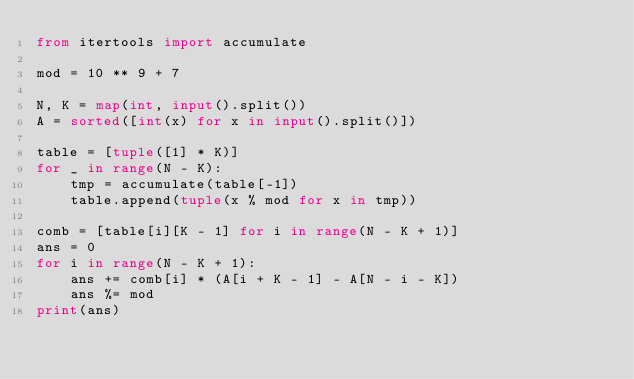Convert code to text. <code><loc_0><loc_0><loc_500><loc_500><_Python_>from itertools import accumulate

mod = 10 ** 9 + 7

N, K = map(int, input().split())
A = sorted([int(x) for x in input().split()])

table = [tuple([1] * K)]
for _ in range(N - K):
    tmp = accumulate(table[-1])
    table.append(tuple(x % mod for x in tmp))

comb = [table[i][K - 1] for i in range(N - K + 1)]
ans = 0
for i in range(N - K + 1):
    ans += comb[i] * (A[i + K - 1] - A[N - i - K])
    ans %= mod
print(ans)
</code> 